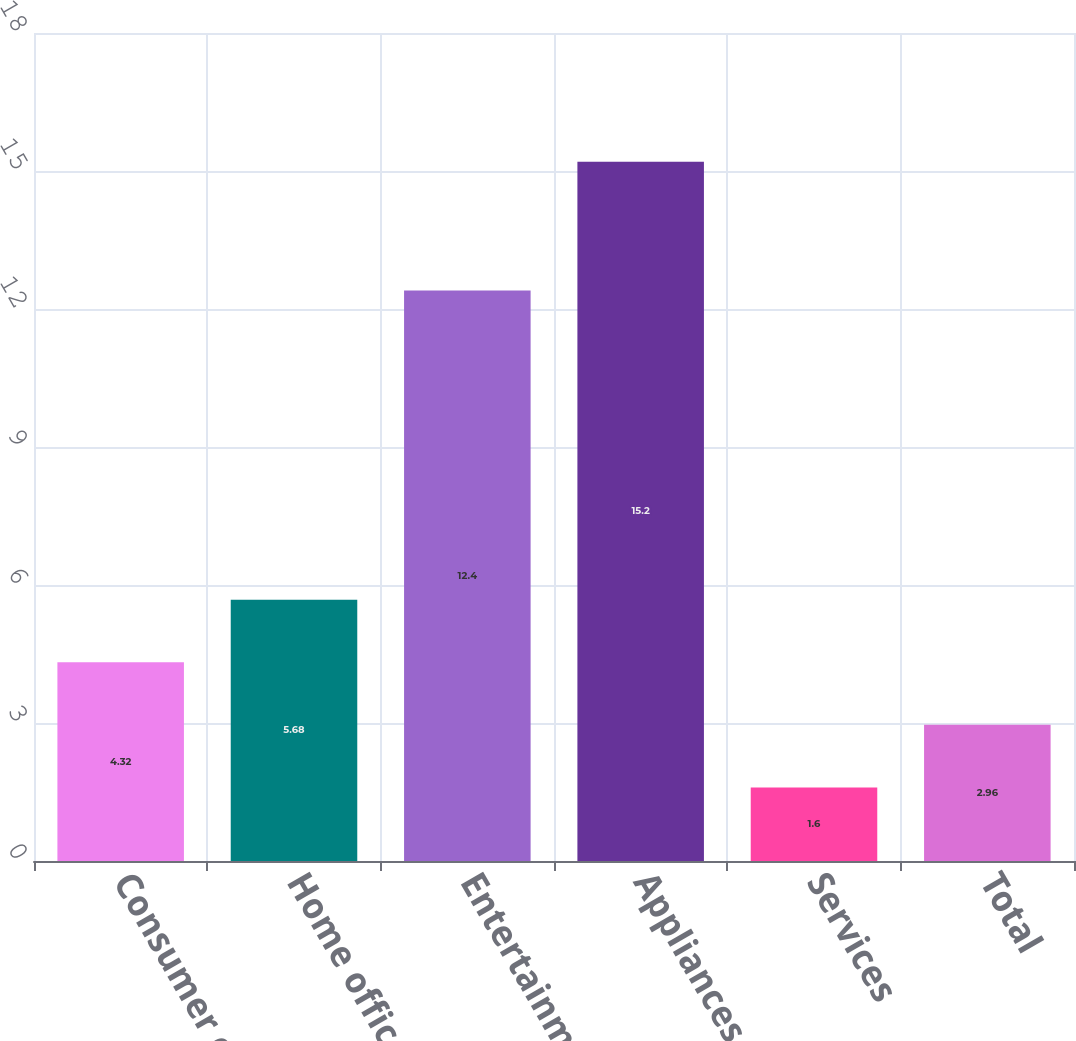<chart> <loc_0><loc_0><loc_500><loc_500><bar_chart><fcel>Consumer electronics<fcel>Home office<fcel>Entertainment<fcel>Appliances<fcel>Services<fcel>Total<nl><fcel>4.32<fcel>5.68<fcel>12.4<fcel>15.2<fcel>1.6<fcel>2.96<nl></chart> 